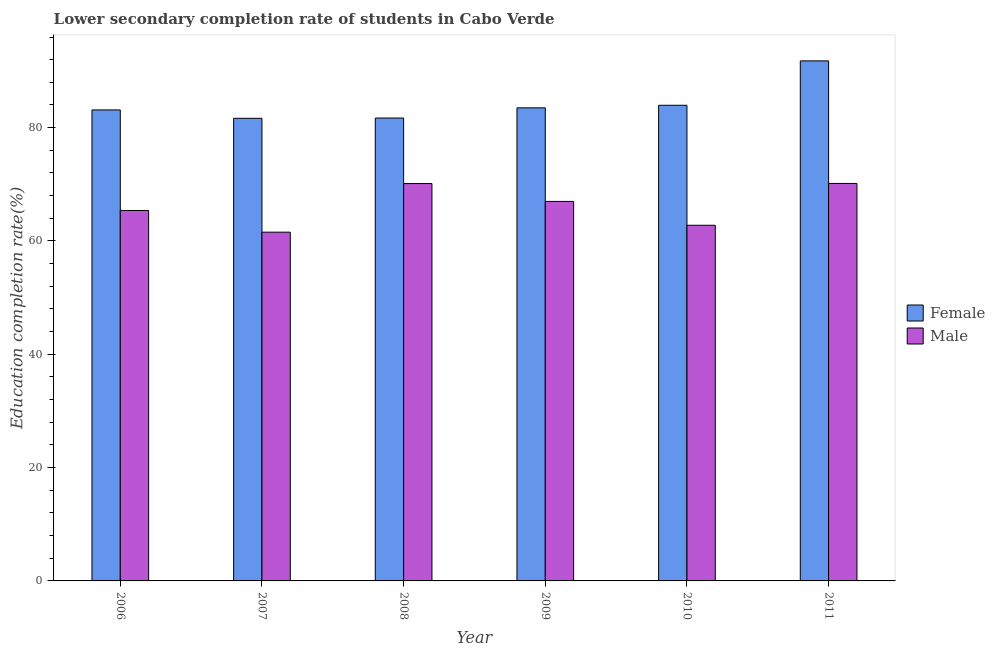How many different coloured bars are there?
Your answer should be compact. 2. How many groups of bars are there?
Keep it short and to the point. 6. How many bars are there on the 3rd tick from the right?
Make the answer very short. 2. What is the label of the 5th group of bars from the left?
Provide a short and direct response. 2010. In how many cases, is the number of bars for a given year not equal to the number of legend labels?
Keep it short and to the point. 0. What is the education completion rate of male students in 2009?
Ensure brevity in your answer.  66.98. Across all years, what is the maximum education completion rate of male students?
Your answer should be compact. 70.15. Across all years, what is the minimum education completion rate of male students?
Ensure brevity in your answer.  61.55. In which year was the education completion rate of male students maximum?
Offer a very short reply. 2011. What is the total education completion rate of male students in the graph?
Your response must be concise. 396.98. What is the difference between the education completion rate of male students in 2009 and that in 2010?
Your answer should be compact. 4.21. What is the difference between the education completion rate of female students in 2009 and the education completion rate of male students in 2008?
Make the answer very short. 1.8. What is the average education completion rate of female students per year?
Offer a terse response. 84.29. In how many years, is the education completion rate of female students greater than 88 %?
Keep it short and to the point. 1. What is the ratio of the education completion rate of female students in 2006 to that in 2008?
Offer a very short reply. 1.02. Is the education completion rate of female students in 2009 less than that in 2011?
Offer a very short reply. Yes. What is the difference between the highest and the second highest education completion rate of male students?
Your answer should be compact. 0.02. What is the difference between the highest and the lowest education completion rate of female students?
Offer a terse response. 10.14. What does the 1st bar from the right in 2006 represents?
Give a very brief answer. Male. How many years are there in the graph?
Offer a very short reply. 6. What is the difference between two consecutive major ticks on the Y-axis?
Your answer should be compact. 20. Are the values on the major ticks of Y-axis written in scientific E-notation?
Provide a short and direct response. No. Does the graph contain any zero values?
Make the answer very short. No. Does the graph contain grids?
Your answer should be very brief. No. Where does the legend appear in the graph?
Ensure brevity in your answer.  Center right. How many legend labels are there?
Offer a very short reply. 2. What is the title of the graph?
Provide a succinct answer. Lower secondary completion rate of students in Cabo Verde. Does "Register a business" appear as one of the legend labels in the graph?
Your response must be concise. No. What is the label or title of the X-axis?
Your response must be concise. Year. What is the label or title of the Y-axis?
Make the answer very short. Education completion rate(%). What is the Education completion rate(%) of Female in 2006?
Make the answer very short. 83.13. What is the Education completion rate(%) in Male in 2006?
Your answer should be very brief. 65.38. What is the Education completion rate(%) in Female in 2007?
Offer a terse response. 81.65. What is the Education completion rate(%) of Male in 2007?
Your answer should be very brief. 61.55. What is the Education completion rate(%) in Female in 2008?
Your answer should be compact. 81.7. What is the Education completion rate(%) in Male in 2008?
Give a very brief answer. 70.13. What is the Education completion rate(%) of Female in 2009?
Keep it short and to the point. 83.5. What is the Education completion rate(%) in Male in 2009?
Provide a short and direct response. 66.98. What is the Education completion rate(%) in Female in 2010?
Keep it short and to the point. 83.95. What is the Education completion rate(%) in Male in 2010?
Your answer should be very brief. 62.77. What is the Education completion rate(%) in Female in 2011?
Provide a short and direct response. 91.79. What is the Education completion rate(%) in Male in 2011?
Give a very brief answer. 70.15. Across all years, what is the maximum Education completion rate(%) in Female?
Your response must be concise. 91.79. Across all years, what is the maximum Education completion rate(%) in Male?
Give a very brief answer. 70.15. Across all years, what is the minimum Education completion rate(%) of Female?
Provide a succinct answer. 81.65. Across all years, what is the minimum Education completion rate(%) in Male?
Offer a very short reply. 61.55. What is the total Education completion rate(%) of Female in the graph?
Provide a short and direct response. 505.71. What is the total Education completion rate(%) of Male in the graph?
Keep it short and to the point. 396.98. What is the difference between the Education completion rate(%) in Female in 2006 and that in 2007?
Provide a short and direct response. 1.48. What is the difference between the Education completion rate(%) in Male in 2006 and that in 2007?
Your answer should be very brief. 3.83. What is the difference between the Education completion rate(%) of Female in 2006 and that in 2008?
Provide a succinct answer. 1.43. What is the difference between the Education completion rate(%) of Male in 2006 and that in 2008?
Give a very brief answer. -4.75. What is the difference between the Education completion rate(%) in Female in 2006 and that in 2009?
Offer a very short reply. -0.37. What is the difference between the Education completion rate(%) in Male in 2006 and that in 2009?
Provide a short and direct response. -1.6. What is the difference between the Education completion rate(%) of Female in 2006 and that in 2010?
Keep it short and to the point. -0.82. What is the difference between the Education completion rate(%) of Male in 2006 and that in 2010?
Provide a short and direct response. 2.61. What is the difference between the Education completion rate(%) in Female in 2006 and that in 2011?
Provide a short and direct response. -8.66. What is the difference between the Education completion rate(%) in Male in 2006 and that in 2011?
Offer a very short reply. -4.77. What is the difference between the Education completion rate(%) of Female in 2007 and that in 2008?
Give a very brief answer. -0.05. What is the difference between the Education completion rate(%) in Male in 2007 and that in 2008?
Ensure brevity in your answer.  -8.58. What is the difference between the Education completion rate(%) of Female in 2007 and that in 2009?
Provide a succinct answer. -1.85. What is the difference between the Education completion rate(%) of Male in 2007 and that in 2009?
Offer a terse response. -5.43. What is the difference between the Education completion rate(%) of Female in 2007 and that in 2010?
Your answer should be compact. -2.3. What is the difference between the Education completion rate(%) of Male in 2007 and that in 2010?
Offer a terse response. -1.22. What is the difference between the Education completion rate(%) of Female in 2007 and that in 2011?
Ensure brevity in your answer.  -10.14. What is the difference between the Education completion rate(%) in Male in 2007 and that in 2011?
Your answer should be very brief. -8.6. What is the difference between the Education completion rate(%) of Female in 2008 and that in 2009?
Provide a short and direct response. -1.8. What is the difference between the Education completion rate(%) of Male in 2008 and that in 2009?
Give a very brief answer. 3.15. What is the difference between the Education completion rate(%) in Female in 2008 and that in 2010?
Your answer should be compact. -2.25. What is the difference between the Education completion rate(%) in Male in 2008 and that in 2010?
Your response must be concise. 7.36. What is the difference between the Education completion rate(%) of Female in 2008 and that in 2011?
Provide a succinct answer. -10.09. What is the difference between the Education completion rate(%) of Male in 2008 and that in 2011?
Provide a succinct answer. -0.02. What is the difference between the Education completion rate(%) of Female in 2009 and that in 2010?
Offer a terse response. -0.45. What is the difference between the Education completion rate(%) in Male in 2009 and that in 2010?
Offer a very short reply. 4.21. What is the difference between the Education completion rate(%) of Female in 2009 and that in 2011?
Your answer should be very brief. -8.29. What is the difference between the Education completion rate(%) of Male in 2009 and that in 2011?
Provide a short and direct response. -3.17. What is the difference between the Education completion rate(%) of Female in 2010 and that in 2011?
Give a very brief answer. -7.84. What is the difference between the Education completion rate(%) of Male in 2010 and that in 2011?
Make the answer very short. -7.38. What is the difference between the Education completion rate(%) in Female in 2006 and the Education completion rate(%) in Male in 2007?
Ensure brevity in your answer.  21.57. What is the difference between the Education completion rate(%) of Female in 2006 and the Education completion rate(%) of Male in 2008?
Your answer should be very brief. 13. What is the difference between the Education completion rate(%) in Female in 2006 and the Education completion rate(%) in Male in 2009?
Give a very brief answer. 16.15. What is the difference between the Education completion rate(%) in Female in 2006 and the Education completion rate(%) in Male in 2010?
Provide a short and direct response. 20.36. What is the difference between the Education completion rate(%) in Female in 2006 and the Education completion rate(%) in Male in 2011?
Your answer should be compact. 12.98. What is the difference between the Education completion rate(%) of Female in 2007 and the Education completion rate(%) of Male in 2008?
Your response must be concise. 11.52. What is the difference between the Education completion rate(%) in Female in 2007 and the Education completion rate(%) in Male in 2009?
Your answer should be very brief. 14.67. What is the difference between the Education completion rate(%) of Female in 2007 and the Education completion rate(%) of Male in 2010?
Keep it short and to the point. 18.88. What is the difference between the Education completion rate(%) of Female in 2007 and the Education completion rate(%) of Male in 2011?
Keep it short and to the point. 11.5. What is the difference between the Education completion rate(%) in Female in 2008 and the Education completion rate(%) in Male in 2009?
Offer a terse response. 14.71. What is the difference between the Education completion rate(%) of Female in 2008 and the Education completion rate(%) of Male in 2010?
Keep it short and to the point. 18.92. What is the difference between the Education completion rate(%) in Female in 2008 and the Education completion rate(%) in Male in 2011?
Keep it short and to the point. 11.54. What is the difference between the Education completion rate(%) in Female in 2009 and the Education completion rate(%) in Male in 2010?
Make the answer very short. 20.72. What is the difference between the Education completion rate(%) of Female in 2009 and the Education completion rate(%) of Male in 2011?
Ensure brevity in your answer.  13.34. What is the difference between the Education completion rate(%) of Female in 2010 and the Education completion rate(%) of Male in 2011?
Your response must be concise. 13.8. What is the average Education completion rate(%) of Female per year?
Ensure brevity in your answer.  84.28. What is the average Education completion rate(%) of Male per year?
Give a very brief answer. 66.16. In the year 2006, what is the difference between the Education completion rate(%) in Female and Education completion rate(%) in Male?
Make the answer very short. 17.75. In the year 2007, what is the difference between the Education completion rate(%) in Female and Education completion rate(%) in Male?
Keep it short and to the point. 20.09. In the year 2008, what is the difference between the Education completion rate(%) of Female and Education completion rate(%) of Male?
Your answer should be compact. 11.56. In the year 2009, what is the difference between the Education completion rate(%) in Female and Education completion rate(%) in Male?
Your response must be concise. 16.52. In the year 2010, what is the difference between the Education completion rate(%) in Female and Education completion rate(%) in Male?
Provide a short and direct response. 21.18. In the year 2011, what is the difference between the Education completion rate(%) in Female and Education completion rate(%) in Male?
Keep it short and to the point. 21.63. What is the ratio of the Education completion rate(%) in Female in 2006 to that in 2007?
Offer a terse response. 1.02. What is the ratio of the Education completion rate(%) in Male in 2006 to that in 2007?
Offer a very short reply. 1.06. What is the ratio of the Education completion rate(%) in Female in 2006 to that in 2008?
Your response must be concise. 1.02. What is the ratio of the Education completion rate(%) in Male in 2006 to that in 2008?
Provide a short and direct response. 0.93. What is the ratio of the Education completion rate(%) in Female in 2006 to that in 2009?
Your answer should be compact. 1. What is the ratio of the Education completion rate(%) in Male in 2006 to that in 2009?
Keep it short and to the point. 0.98. What is the ratio of the Education completion rate(%) in Female in 2006 to that in 2010?
Make the answer very short. 0.99. What is the ratio of the Education completion rate(%) of Male in 2006 to that in 2010?
Your answer should be very brief. 1.04. What is the ratio of the Education completion rate(%) of Female in 2006 to that in 2011?
Provide a short and direct response. 0.91. What is the ratio of the Education completion rate(%) in Male in 2006 to that in 2011?
Give a very brief answer. 0.93. What is the ratio of the Education completion rate(%) of Female in 2007 to that in 2008?
Make the answer very short. 1. What is the ratio of the Education completion rate(%) in Male in 2007 to that in 2008?
Your answer should be compact. 0.88. What is the ratio of the Education completion rate(%) of Female in 2007 to that in 2009?
Your answer should be compact. 0.98. What is the ratio of the Education completion rate(%) of Male in 2007 to that in 2009?
Keep it short and to the point. 0.92. What is the ratio of the Education completion rate(%) in Female in 2007 to that in 2010?
Offer a terse response. 0.97. What is the ratio of the Education completion rate(%) of Male in 2007 to that in 2010?
Provide a short and direct response. 0.98. What is the ratio of the Education completion rate(%) in Female in 2007 to that in 2011?
Give a very brief answer. 0.89. What is the ratio of the Education completion rate(%) in Male in 2007 to that in 2011?
Offer a very short reply. 0.88. What is the ratio of the Education completion rate(%) in Female in 2008 to that in 2009?
Make the answer very short. 0.98. What is the ratio of the Education completion rate(%) of Male in 2008 to that in 2009?
Offer a terse response. 1.05. What is the ratio of the Education completion rate(%) in Female in 2008 to that in 2010?
Provide a short and direct response. 0.97. What is the ratio of the Education completion rate(%) of Male in 2008 to that in 2010?
Provide a succinct answer. 1.12. What is the ratio of the Education completion rate(%) in Female in 2008 to that in 2011?
Provide a succinct answer. 0.89. What is the ratio of the Education completion rate(%) in Male in 2008 to that in 2011?
Give a very brief answer. 1. What is the ratio of the Education completion rate(%) of Male in 2009 to that in 2010?
Make the answer very short. 1.07. What is the ratio of the Education completion rate(%) in Female in 2009 to that in 2011?
Offer a terse response. 0.91. What is the ratio of the Education completion rate(%) in Male in 2009 to that in 2011?
Ensure brevity in your answer.  0.95. What is the ratio of the Education completion rate(%) of Female in 2010 to that in 2011?
Offer a very short reply. 0.91. What is the ratio of the Education completion rate(%) of Male in 2010 to that in 2011?
Your answer should be compact. 0.89. What is the difference between the highest and the second highest Education completion rate(%) in Female?
Your answer should be compact. 7.84. What is the difference between the highest and the second highest Education completion rate(%) in Male?
Make the answer very short. 0.02. What is the difference between the highest and the lowest Education completion rate(%) in Female?
Offer a very short reply. 10.14. What is the difference between the highest and the lowest Education completion rate(%) of Male?
Ensure brevity in your answer.  8.6. 